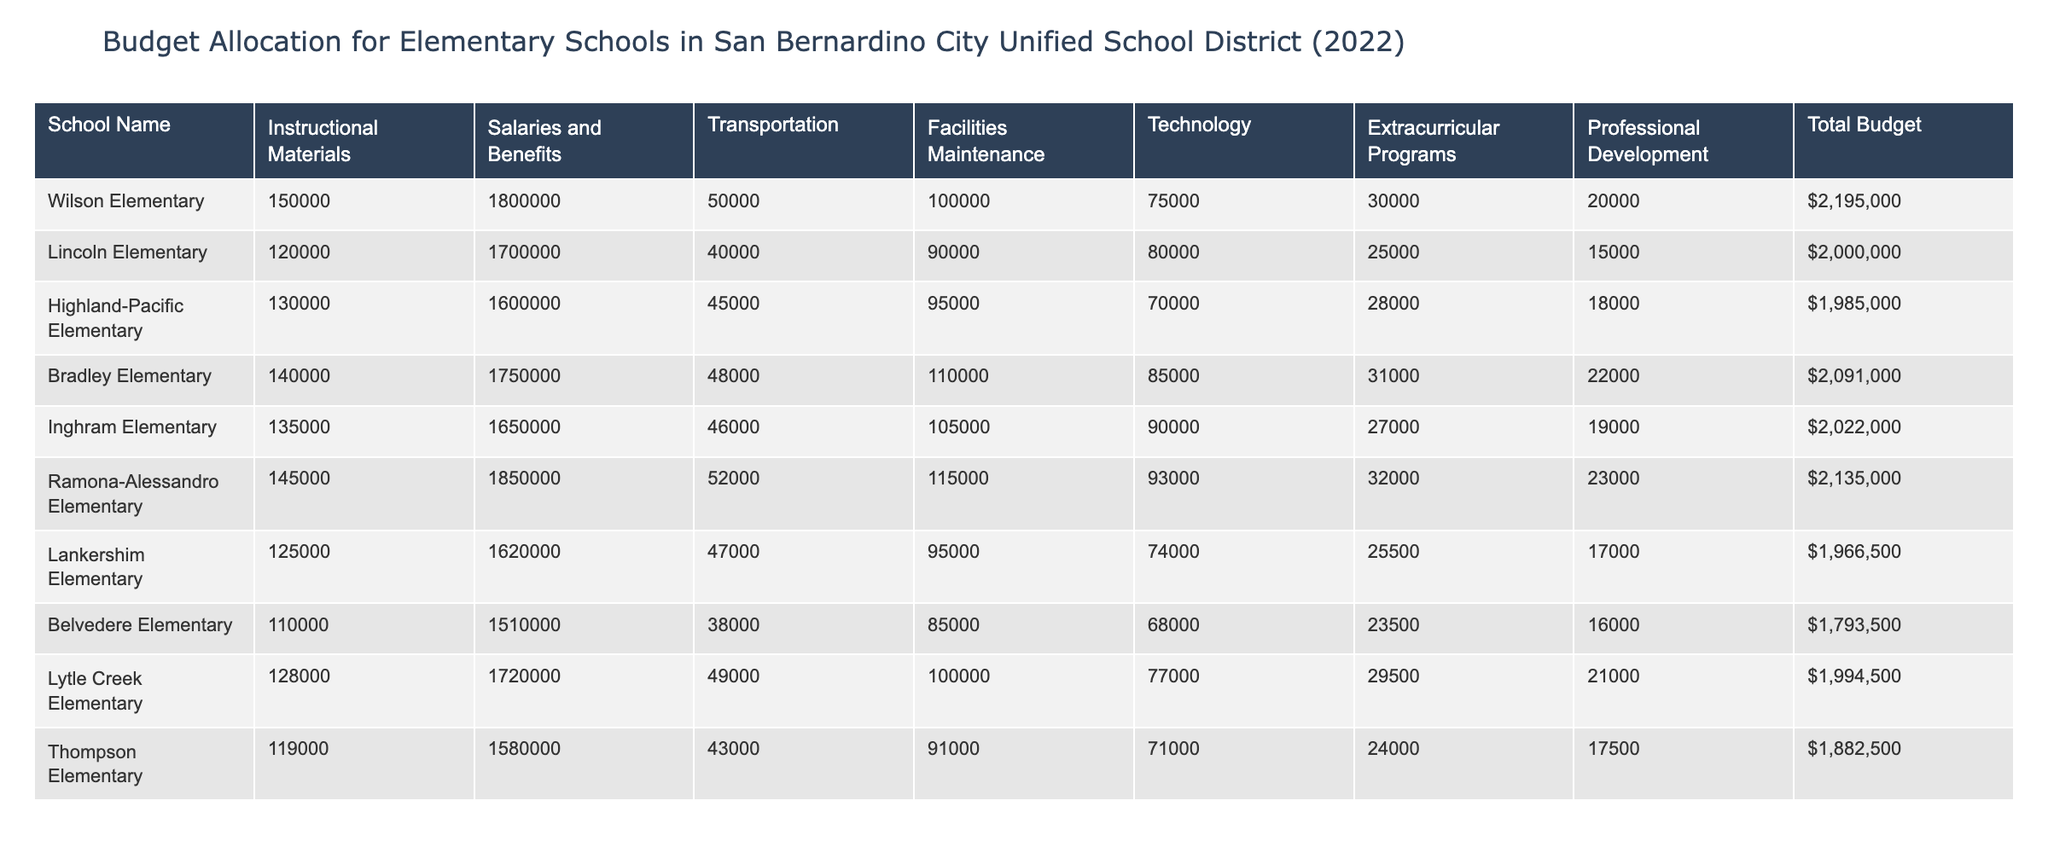What is the total budget for Wilson Elementary? Wilson Elementary has a total budget listed in the table which is found in the "Total Budget" column. The value corresponding to Wilson Elementary is 2,195,000.
Answer: 2,195,000 What is the budget allocated for salaries and benefits at Lincoln Elementary? The "Salaries and Benefits" column provides the relevant information for Lincoln Elementary. The value is 1,700,000.
Answer: 1,700,000 Which school has the highest allocation for transportation, and what is that amount? To find this, we look at the "Transportation" column for each school and compare the values. Ramona-Alessandro Elementary has the highest transportation cost at 52,000.
Answer: Ramona-Alessandro Elementary, 52,000 What is the average budget allocation for facilities maintenance across all schools? We sum all values in the "Facilities Maintenance" column: 100,000 + 90,000 + 95,000 + 110,000 + 105,000 + 115,000 + 95,000 + 85,000 + 100,000 + 91,000 = 1,062,000. Then divide by the number of schools, which is 10. So, the average is 1,062,000 / 10 = 106,200.
Answer: 106,200 Is the total budget for Lankershim Elementary greater than 2 million? We check the "Total Budget" value for Lankershim Elementary, which is 1,966,500. Since this value is less than 2 million, the answer is no.
Answer: No Which school spent the least on technology, and what was the amount? By examining the "Technology" column, we find that Belvedere Elementary has the lowest allocation at 68,000.
Answer: Belvedere Elementary, 68,000 How much more did Highland-Pacific Elementary allocate to professional development compared to Thompson Elementary? First, we find the values for professional development: Highland-Pacific Elementary has 18,000, and Thompson Elementary has 17,500. We subtract: 18,000 - 17,500 = 500. Thus, Highland-Pacific allocated 500 more.
Answer: 500 Which school had the total budget closest to the mean total budget of all schools? To find the mean total budget, we calculate the total budget sum: 2,195,000 + 2,000,000 + 1,985,000 + 2,091,000 + 2,022,000 + 2,135,000 + 1,966,500 + 1,793,500 + 1,994,500 + 1,882,500 = 20,990,000. Dividing by 10 gives a mean of 2,099,000. The total budgets closest to this mean are Ramona-Alessandro Elementary at 2,135,000 and Bradley Elementary at 2,091,000.
Answer: Ramona-Alessandro Elementary, 2,135,000 and Bradley Elementary, 2,091,000 